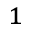<formula> <loc_0><loc_0><loc_500><loc_500>^ { 1 }</formula> 